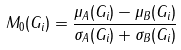Convert formula to latex. <formula><loc_0><loc_0><loc_500><loc_500>M _ { 0 } ( G _ { i } ) = \frac { \mu _ { A } ( G _ { i } ) - \mu _ { B } ( G _ { i } ) } { \sigma _ { A } ( G _ { i } ) + \sigma _ { B } ( G _ { i } ) }</formula> 